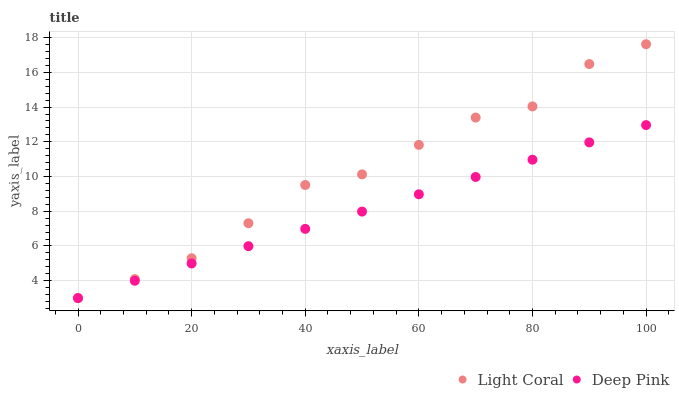Does Deep Pink have the minimum area under the curve?
Answer yes or no. Yes. Does Light Coral have the maximum area under the curve?
Answer yes or no. Yes. Does Deep Pink have the maximum area under the curve?
Answer yes or no. No. Is Deep Pink the smoothest?
Answer yes or no. Yes. Is Light Coral the roughest?
Answer yes or no. Yes. Is Deep Pink the roughest?
Answer yes or no. No. Does Light Coral have the lowest value?
Answer yes or no. Yes. Does Light Coral have the highest value?
Answer yes or no. Yes. Does Deep Pink have the highest value?
Answer yes or no. No. Does Deep Pink intersect Light Coral?
Answer yes or no. Yes. Is Deep Pink less than Light Coral?
Answer yes or no. No. Is Deep Pink greater than Light Coral?
Answer yes or no. No. 